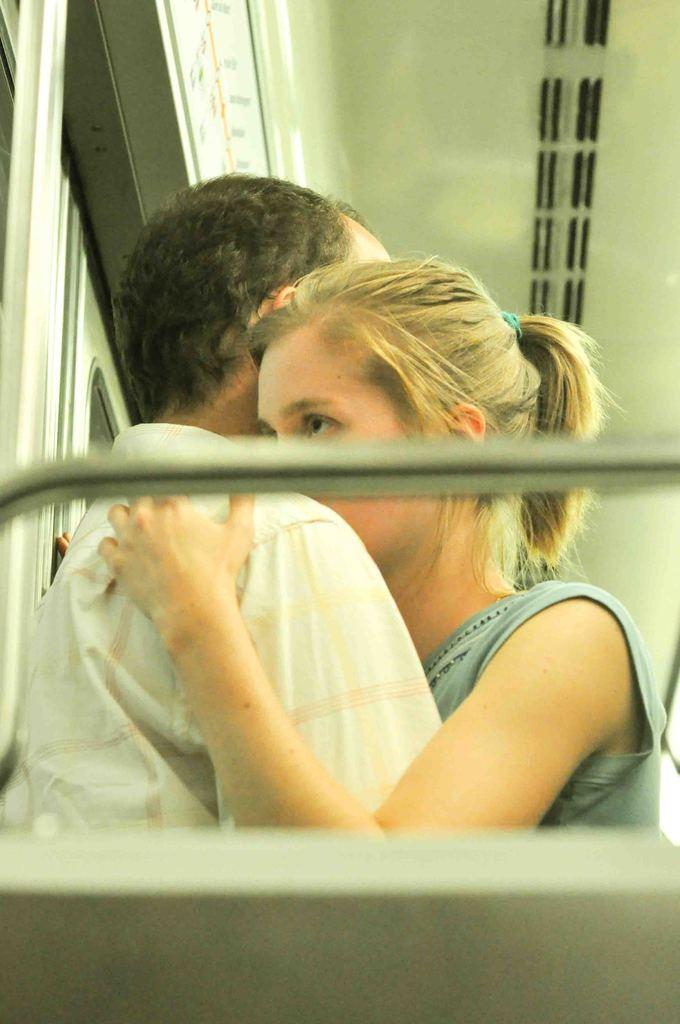Describe this image in one or two sentences. The image is taken in the train. In the center of the image we can see a man and a lady hugging each other. On the left there is a window. 